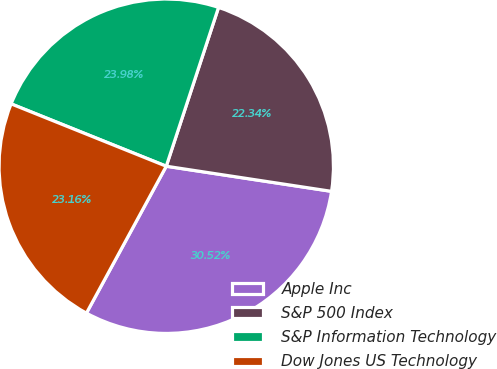Convert chart to OTSL. <chart><loc_0><loc_0><loc_500><loc_500><pie_chart><fcel>Apple Inc<fcel>S&P 500 Index<fcel>S&P Information Technology<fcel>Dow Jones US Technology<nl><fcel>30.52%<fcel>22.34%<fcel>23.98%<fcel>23.16%<nl></chart> 